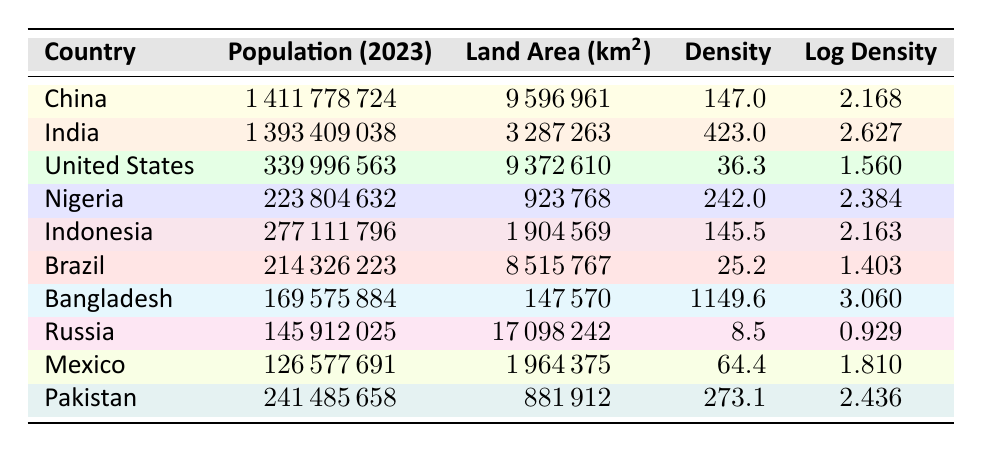What is the population density of Bangladesh in 2023? From the table, we can directly look at the row for Bangladesh and find the density value listed under the Density column, which is 1149.6.
Answer: 1149.6 Which country has the highest population density among the listed countries? By examining the Density column in the table, we can compare all the values and see that Bangladesh has a density of 1149.6, which is greater than all other countries listed.
Answer: Bangladesh What is the total population of Nigeria and Pakistan combined? We refer to the Population columns for both Nigeria (223804632) and Pakistan (241485658). Adding these together: 223804632 + 241485658 equals 465290290.
Answer: 465290290 Is the log density of China greater than that of the United States? We compare the Log Density column values: China has a log density of 2.168, and United States has 1.560. Since 2.168 is greater than 1.560, the answer is yes.
Answer: Yes What is the average population density of the countries listed in the table? We first need to sum up the population densities of all countries: 147.0 (China) + 423.0 (India) + 36.3 (United States) + 242.0 (Nigeria) + 145.5 (Indonesia) + 25.2 (Brazil) + 1149.6 (Bangladesh) + 8.5 (Russia) + 64.4 (Mexico) + 273.1 (Pakistan) = 2268.2. There are a total of 10 countries, so we divide the sum by 10: 2268.2 / 10 = 226.82.
Answer: 226.82 Which country has the lowest population density, and what is that value? Looking at the Density column, we see that Russia has the lowest density of 8.5, which we can confirm by checking all other countries' density values.
Answer: Russia, 8.5 How much denser is India's population compared to China’s? First, we subtract China's density (147.0) from India's density (423.0): 423.0 - 147.0 equals 276.0. This calculation shows that India's population density is 276.0 greater than China's.
Answer: 276.0 